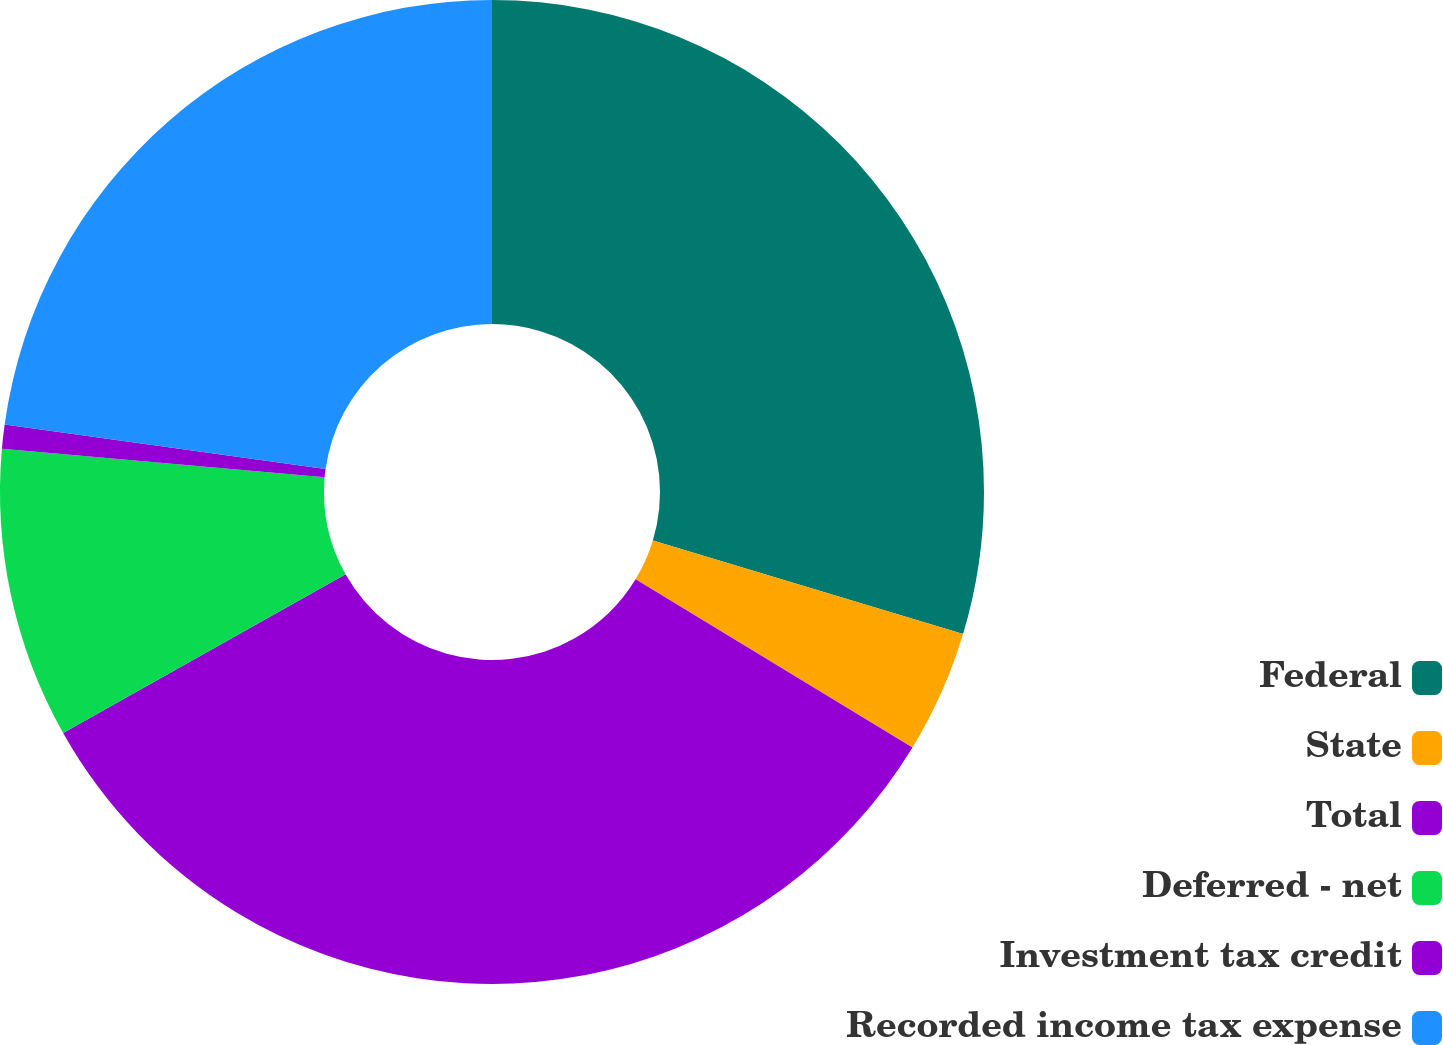<chart> <loc_0><loc_0><loc_500><loc_500><pie_chart><fcel>Federal<fcel>State<fcel>Total<fcel>Deferred - net<fcel>Investment tax credit<fcel>Recorded income tax expense<nl><fcel>29.66%<fcel>4.03%<fcel>33.16%<fcel>9.55%<fcel>0.79%<fcel>22.81%<nl></chart> 